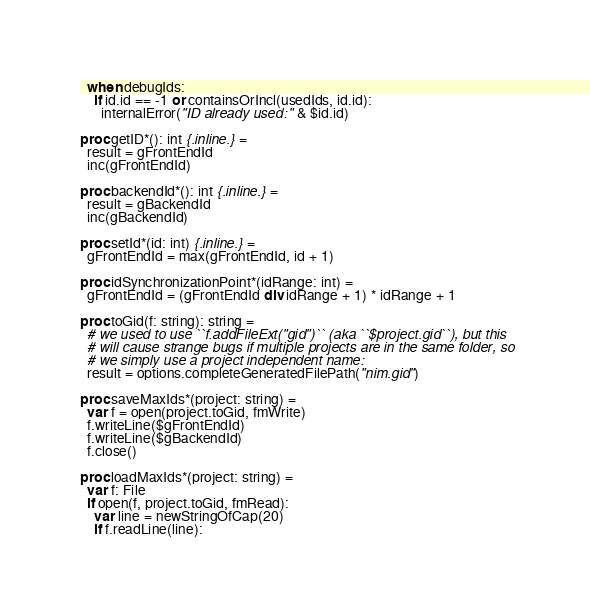<code> <loc_0><loc_0><loc_500><loc_500><_Nim_>  when debugIds:
    if id.id == -1 or containsOrIncl(usedIds, id.id):
      internalError("ID already used: " & $id.id)

proc getID*(): int {.inline.} =
  result = gFrontEndId
  inc(gFrontEndId)

proc backendId*(): int {.inline.} =
  result = gBackendId
  inc(gBackendId)

proc setId*(id: int) {.inline.} =
  gFrontEndId = max(gFrontEndId, id + 1)

proc idSynchronizationPoint*(idRange: int) =
  gFrontEndId = (gFrontEndId div idRange + 1) * idRange + 1

proc toGid(f: string): string =
  # we used to use ``f.addFileExt("gid")`` (aka ``$project.gid``), but this
  # will cause strange bugs if multiple projects are in the same folder, so
  # we simply use a project independent name:
  result = options.completeGeneratedFilePath("nim.gid")

proc saveMaxIds*(project: string) =
  var f = open(project.toGid, fmWrite)
  f.writeLine($gFrontEndId)
  f.writeLine($gBackendId)
  f.close()

proc loadMaxIds*(project: string) =
  var f: File
  if open(f, project.toGid, fmRead):
    var line = newStringOfCap(20)
    if f.readLine(line):</code> 